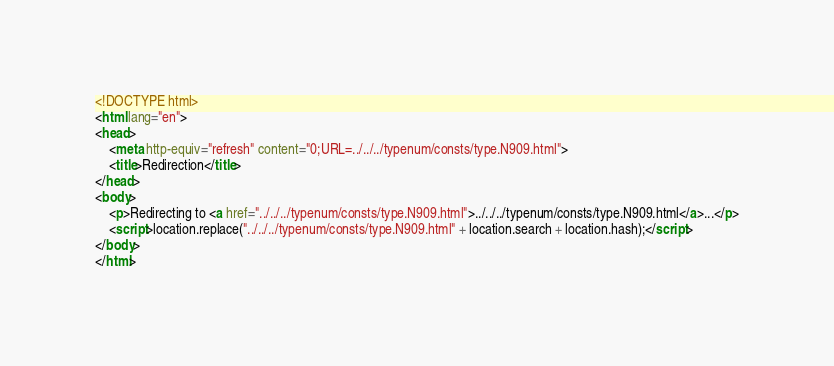<code> <loc_0><loc_0><loc_500><loc_500><_HTML_><!DOCTYPE html>
<html lang="en">
<head>
    <meta http-equiv="refresh" content="0;URL=../../../typenum/consts/type.N909.html">
    <title>Redirection</title>
</head>
<body>
    <p>Redirecting to <a href="../../../typenum/consts/type.N909.html">../../../typenum/consts/type.N909.html</a>...</p>
    <script>location.replace("../../../typenum/consts/type.N909.html" + location.search + location.hash);</script>
</body>
</html></code> 